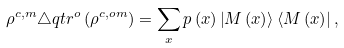Convert formula to latex. <formula><loc_0><loc_0><loc_500><loc_500>\rho ^ { c , m } \triangle q t r ^ { o } \left ( \rho ^ { c , o m } \right ) = \sum _ { x } p \left ( x \right ) \left | M \left ( x \right ) \right > \left < M \left ( x \right ) \right | ,</formula> 